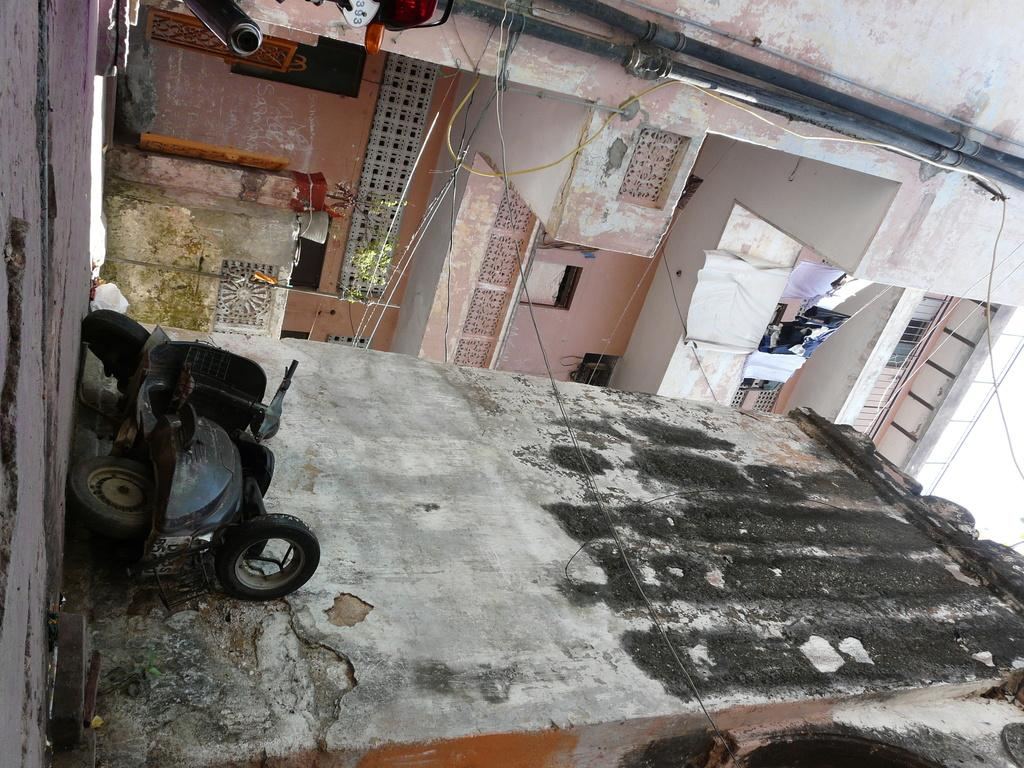What vehicle is present in the image? There is a scooter in the image. Where is the scooter located in relation to the building? The scooter is beside the building. What type of structure is in front of the building? There is an apartment in front of the building. What type of bells can be heard ringing in the image? There are no bells present in the image, and therefore no sound can be heard. 